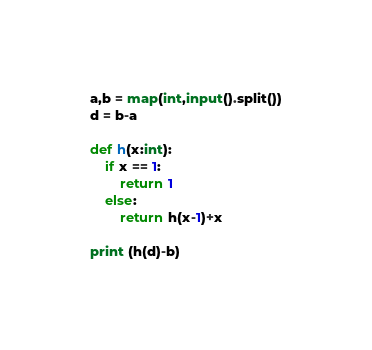Convert code to text. <code><loc_0><loc_0><loc_500><loc_500><_Python_>a,b = map(int,input().split())
d = b-a

def h(x:int):
    if x == 1:
        return 1
    else:
        return h(x-1)+x

print (h(d)-b)
</code> 